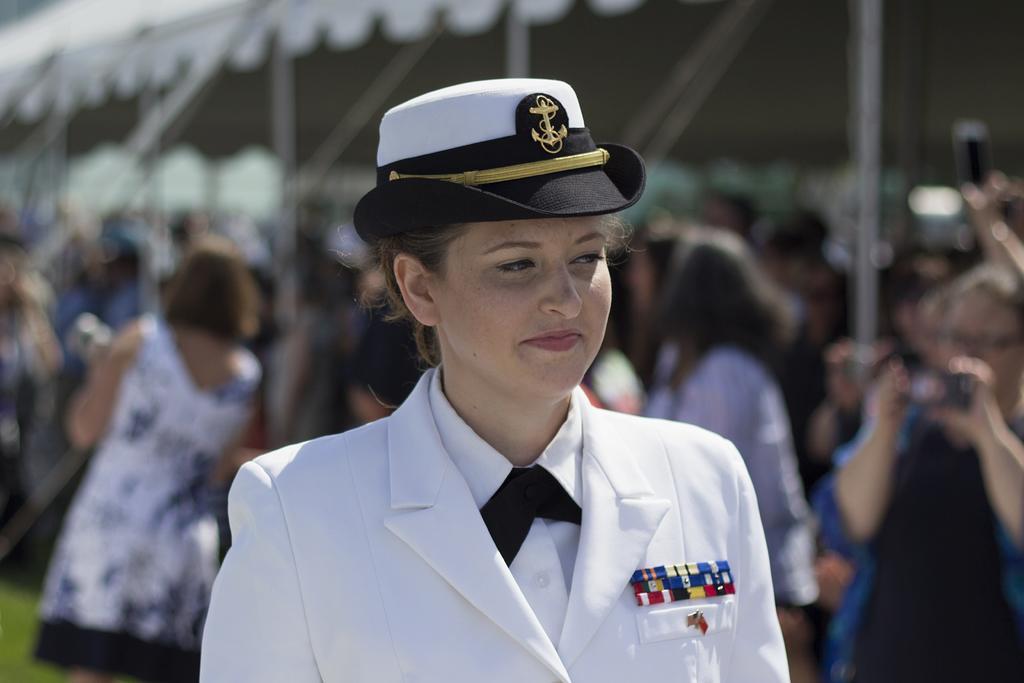How would you summarize this image in a sentence or two? There is a woman smiling and wore cap. In the background it is blurry and we can see people and grass. 